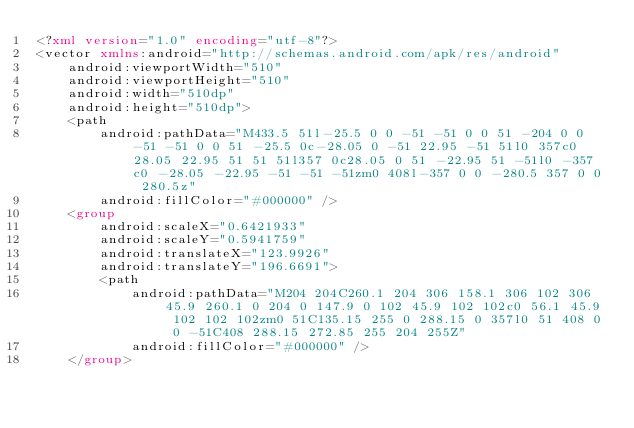Convert code to text. <code><loc_0><loc_0><loc_500><loc_500><_XML_><?xml version="1.0" encoding="utf-8"?>
<vector xmlns:android="http://schemas.android.com/apk/res/android"
    android:viewportWidth="510"
    android:viewportHeight="510"
    android:width="510dp"
    android:height="510dp">
    <path
        android:pathData="M433.5 51l-25.5 0 0 -51 -51 0 0 51 -204 0 0 -51 -51 0 0 51 -25.5 0c-28.05 0 -51 22.95 -51 51l0 357c0 28.05 22.95 51 51 51l357 0c28.05 0 51 -22.95 51 -51l0 -357c0 -28.05 -22.95 -51 -51 -51zm0 408l-357 0 0 -280.5 357 0 0 280.5z"
        android:fillColor="#000000" />
    <group
        android:scaleX="0.6421933"
        android:scaleY="0.5941759"
        android:translateX="123.9926"
        android:translateY="196.6691">
        <path
            android:pathData="M204 204C260.1 204 306 158.1 306 102 306 45.9 260.1 0 204 0 147.9 0 102 45.9 102 102c0 56.1 45.9 102 102 102zm0 51C135.15 255 0 288.15 0 357l0 51 408 0 0 -51C408 288.15 272.85 255 204 255Z"
            android:fillColor="#000000" />
    </group></code> 